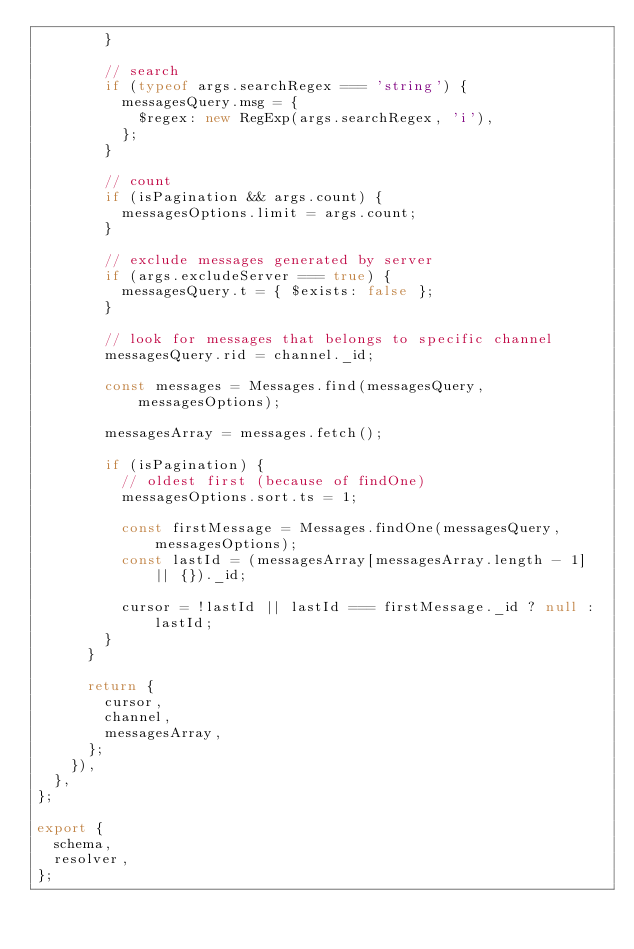<code> <loc_0><loc_0><loc_500><loc_500><_JavaScript_>				}

				// search
				if (typeof args.searchRegex === 'string') {
					messagesQuery.msg = {
						$regex: new RegExp(args.searchRegex, 'i'),
					};
				}

				// count
				if (isPagination && args.count) {
					messagesOptions.limit = args.count;
				}

				// exclude messages generated by server
				if (args.excludeServer === true) {
					messagesQuery.t = { $exists: false };
				}

				// look for messages that belongs to specific channel
				messagesQuery.rid = channel._id;

				const messages = Messages.find(messagesQuery, messagesOptions);

				messagesArray = messages.fetch();

				if (isPagination) {
					// oldest first (because of findOne)
					messagesOptions.sort.ts = 1;

					const firstMessage = Messages.findOne(messagesQuery, messagesOptions);
					const lastId = (messagesArray[messagesArray.length - 1] || {})._id;

					cursor = !lastId || lastId === firstMessage._id ? null : lastId;
				}
			}

			return {
				cursor,
				channel,
				messagesArray,
			};
		}),
	},
};

export {
	schema,
	resolver,
};
</code> 